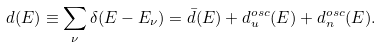<formula> <loc_0><loc_0><loc_500><loc_500>d ( E ) \equiv \sum _ { \nu } \delta ( E - E _ { \nu } ) = \bar { d } ( E ) + d _ { u } ^ { o s c } ( E ) + d _ { n } ^ { o s c } ( E ) .</formula> 